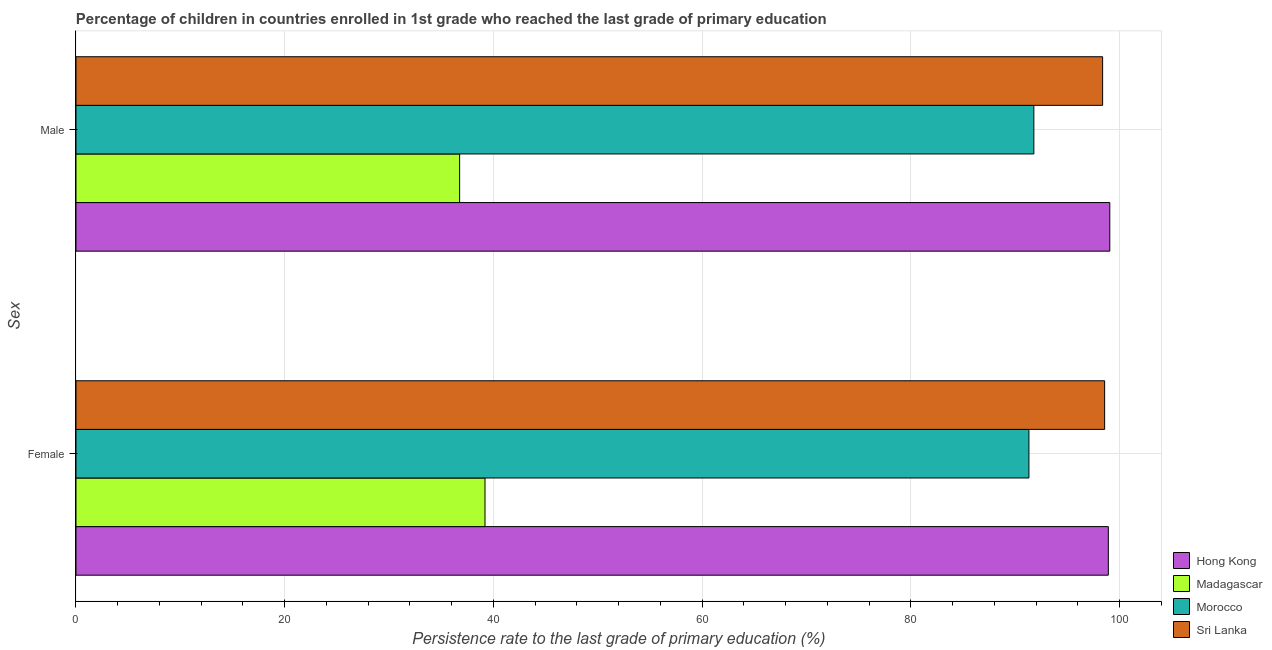How many groups of bars are there?
Provide a short and direct response. 2. Are the number of bars on each tick of the Y-axis equal?
Your response must be concise. Yes. What is the label of the 1st group of bars from the top?
Your answer should be very brief. Male. What is the persistence rate of male students in Morocco?
Your response must be concise. 91.79. Across all countries, what is the maximum persistence rate of female students?
Your response must be concise. 98.92. Across all countries, what is the minimum persistence rate of male students?
Provide a short and direct response. 36.76. In which country was the persistence rate of female students maximum?
Offer a very short reply. Hong Kong. In which country was the persistence rate of female students minimum?
Provide a succinct answer. Madagascar. What is the total persistence rate of male students in the graph?
Ensure brevity in your answer.  325.99. What is the difference between the persistence rate of male students in Madagascar and that in Morocco?
Your response must be concise. -55.03. What is the difference between the persistence rate of female students in Sri Lanka and the persistence rate of male students in Morocco?
Ensure brevity in your answer.  6.78. What is the average persistence rate of male students per country?
Your answer should be compact. 81.5. What is the difference between the persistence rate of male students and persistence rate of female students in Morocco?
Offer a terse response. 0.47. In how many countries, is the persistence rate of male students greater than 4 %?
Your response must be concise. 4. What is the ratio of the persistence rate of male students in Morocco to that in Hong Kong?
Give a very brief answer. 0.93. Is the persistence rate of male students in Madagascar less than that in Sri Lanka?
Provide a succinct answer. Yes. In how many countries, is the persistence rate of female students greater than the average persistence rate of female students taken over all countries?
Offer a very short reply. 3. What does the 4th bar from the top in Male represents?
Your answer should be compact. Hong Kong. What does the 4th bar from the bottom in Female represents?
Give a very brief answer. Sri Lanka. Are all the bars in the graph horizontal?
Keep it short and to the point. Yes. How many countries are there in the graph?
Offer a very short reply. 4. Are the values on the major ticks of X-axis written in scientific E-notation?
Provide a short and direct response. No. Does the graph contain grids?
Your answer should be compact. Yes. How many legend labels are there?
Your answer should be very brief. 4. What is the title of the graph?
Provide a succinct answer. Percentage of children in countries enrolled in 1st grade who reached the last grade of primary education. Does "Norway" appear as one of the legend labels in the graph?
Ensure brevity in your answer.  No. What is the label or title of the X-axis?
Your answer should be very brief. Persistence rate to the last grade of primary education (%). What is the label or title of the Y-axis?
Offer a terse response. Sex. What is the Persistence rate to the last grade of primary education (%) of Hong Kong in Female?
Your answer should be compact. 98.92. What is the Persistence rate to the last grade of primary education (%) in Madagascar in Female?
Your answer should be compact. 39.19. What is the Persistence rate to the last grade of primary education (%) of Morocco in Female?
Provide a succinct answer. 91.32. What is the Persistence rate to the last grade of primary education (%) of Sri Lanka in Female?
Give a very brief answer. 98.57. What is the Persistence rate to the last grade of primary education (%) of Hong Kong in Male?
Your response must be concise. 99.07. What is the Persistence rate to the last grade of primary education (%) of Madagascar in Male?
Your answer should be very brief. 36.76. What is the Persistence rate to the last grade of primary education (%) of Morocco in Male?
Offer a very short reply. 91.79. What is the Persistence rate to the last grade of primary education (%) of Sri Lanka in Male?
Offer a very short reply. 98.38. Across all Sex, what is the maximum Persistence rate to the last grade of primary education (%) in Hong Kong?
Keep it short and to the point. 99.07. Across all Sex, what is the maximum Persistence rate to the last grade of primary education (%) in Madagascar?
Give a very brief answer. 39.19. Across all Sex, what is the maximum Persistence rate to the last grade of primary education (%) in Morocco?
Offer a terse response. 91.79. Across all Sex, what is the maximum Persistence rate to the last grade of primary education (%) of Sri Lanka?
Make the answer very short. 98.57. Across all Sex, what is the minimum Persistence rate to the last grade of primary education (%) in Hong Kong?
Keep it short and to the point. 98.92. Across all Sex, what is the minimum Persistence rate to the last grade of primary education (%) of Madagascar?
Ensure brevity in your answer.  36.76. Across all Sex, what is the minimum Persistence rate to the last grade of primary education (%) in Morocco?
Offer a very short reply. 91.32. Across all Sex, what is the minimum Persistence rate to the last grade of primary education (%) in Sri Lanka?
Your answer should be compact. 98.38. What is the total Persistence rate to the last grade of primary education (%) in Hong Kong in the graph?
Your answer should be very brief. 197.99. What is the total Persistence rate to the last grade of primary education (%) in Madagascar in the graph?
Provide a short and direct response. 75.96. What is the total Persistence rate to the last grade of primary education (%) of Morocco in the graph?
Provide a succinct answer. 183.1. What is the total Persistence rate to the last grade of primary education (%) of Sri Lanka in the graph?
Offer a terse response. 196.95. What is the difference between the Persistence rate to the last grade of primary education (%) in Hong Kong in Female and that in Male?
Ensure brevity in your answer.  -0.14. What is the difference between the Persistence rate to the last grade of primary education (%) of Madagascar in Female and that in Male?
Your answer should be compact. 2.43. What is the difference between the Persistence rate to the last grade of primary education (%) in Morocco in Female and that in Male?
Your response must be concise. -0.47. What is the difference between the Persistence rate to the last grade of primary education (%) in Sri Lanka in Female and that in Male?
Ensure brevity in your answer.  0.19. What is the difference between the Persistence rate to the last grade of primary education (%) of Hong Kong in Female and the Persistence rate to the last grade of primary education (%) of Madagascar in Male?
Provide a short and direct response. 62.16. What is the difference between the Persistence rate to the last grade of primary education (%) of Hong Kong in Female and the Persistence rate to the last grade of primary education (%) of Morocco in Male?
Your answer should be compact. 7.14. What is the difference between the Persistence rate to the last grade of primary education (%) of Hong Kong in Female and the Persistence rate to the last grade of primary education (%) of Sri Lanka in Male?
Provide a short and direct response. 0.55. What is the difference between the Persistence rate to the last grade of primary education (%) in Madagascar in Female and the Persistence rate to the last grade of primary education (%) in Morocco in Male?
Your response must be concise. -52.59. What is the difference between the Persistence rate to the last grade of primary education (%) of Madagascar in Female and the Persistence rate to the last grade of primary education (%) of Sri Lanka in Male?
Offer a very short reply. -59.18. What is the difference between the Persistence rate to the last grade of primary education (%) in Morocco in Female and the Persistence rate to the last grade of primary education (%) in Sri Lanka in Male?
Make the answer very short. -7.06. What is the average Persistence rate to the last grade of primary education (%) of Hong Kong per Sex?
Provide a short and direct response. 98.99. What is the average Persistence rate to the last grade of primary education (%) in Madagascar per Sex?
Your response must be concise. 37.98. What is the average Persistence rate to the last grade of primary education (%) in Morocco per Sex?
Give a very brief answer. 91.55. What is the average Persistence rate to the last grade of primary education (%) in Sri Lanka per Sex?
Ensure brevity in your answer.  98.47. What is the difference between the Persistence rate to the last grade of primary education (%) in Hong Kong and Persistence rate to the last grade of primary education (%) in Madagascar in Female?
Your response must be concise. 59.73. What is the difference between the Persistence rate to the last grade of primary education (%) of Hong Kong and Persistence rate to the last grade of primary education (%) of Morocco in Female?
Provide a succinct answer. 7.61. What is the difference between the Persistence rate to the last grade of primary education (%) in Hong Kong and Persistence rate to the last grade of primary education (%) in Sri Lanka in Female?
Your answer should be very brief. 0.35. What is the difference between the Persistence rate to the last grade of primary education (%) in Madagascar and Persistence rate to the last grade of primary education (%) in Morocco in Female?
Give a very brief answer. -52.12. What is the difference between the Persistence rate to the last grade of primary education (%) in Madagascar and Persistence rate to the last grade of primary education (%) in Sri Lanka in Female?
Your answer should be compact. -59.38. What is the difference between the Persistence rate to the last grade of primary education (%) in Morocco and Persistence rate to the last grade of primary education (%) in Sri Lanka in Female?
Your answer should be very brief. -7.26. What is the difference between the Persistence rate to the last grade of primary education (%) of Hong Kong and Persistence rate to the last grade of primary education (%) of Madagascar in Male?
Keep it short and to the point. 62.3. What is the difference between the Persistence rate to the last grade of primary education (%) in Hong Kong and Persistence rate to the last grade of primary education (%) in Morocco in Male?
Your answer should be very brief. 7.28. What is the difference between the Persistence rate to the last grade of primary education (%) of Hong Kong and Persistence rate to the last grade of primary education (%) of Sri Lanka in Male?
Your answer should be very brief. 0.69. What is the difference between the Persistence rate to the last grade of primary education (%) in Madagascar and Persistence rate to the last grade of primary education (%) in Morocco in Male?
Your response must be concise. -55.03. What is the difference between the Persistence rate to the last grade of primary education (%) of Madagascar and Persistence rate to the last grade of primary education (%) of Sri Lanka in Male?
Your response must be concise. -61.61. What is the difference between the Persistence rate to the last grade of primary education (%) in Morocco and Persistence rate to the last grade of primary education (%) in Sri Lanka in Male?
Provide a short and direct response. -6.59. What is the ratio of the Persistence rate to the last grade of primary education (%) of Hong Kong in Female to that in Male?
Provide a succinct answer. 1. What is the ratio of the Persistence rate to the last grade of primary education (%) in Madagascar in Female to that in Male?
Provide a succinct answer. 1.07. What is the difference between the highest and the second highest Persistence rate to the last grade of primary education (%) of Hong Kong?
Your answer should be compact. 0.14. What is the difference between the highest and the second highest Persistence rate to the last grade of primary education (%) of Madagascar?
Your answer should be very brief. 2.43. What is the difference between the highest and the second highest Persistence rate to the last grade of primary education (%) in Morocco?
Make the answer very short. 0.47. What is the difference between the highest and the second highest Persistence rate to the last grade of primary education (%) in Sri Lanka?
Give a very brief answer. 0.19. What is the difference between the highest and the lowest Persistence rate to the last grade of primary education (%) of Hong Kong?
Provide a succinct answer. 0.14. What is the difference between the highest and the lowest Persistence rate to the last grade of primary education (%) in Madagascar?
Your answer should be compact. 2.43. What is the difference between the highest and the lowest Persistence rate to the last grade of primary education (%) of Morocco?
Give a very brief answer. 0.47. What is the difference between the highest and the lowest Persistence rate to the last grade of primary education (%) of Sri Lanka?
Give a very brief answer. 0.19. 